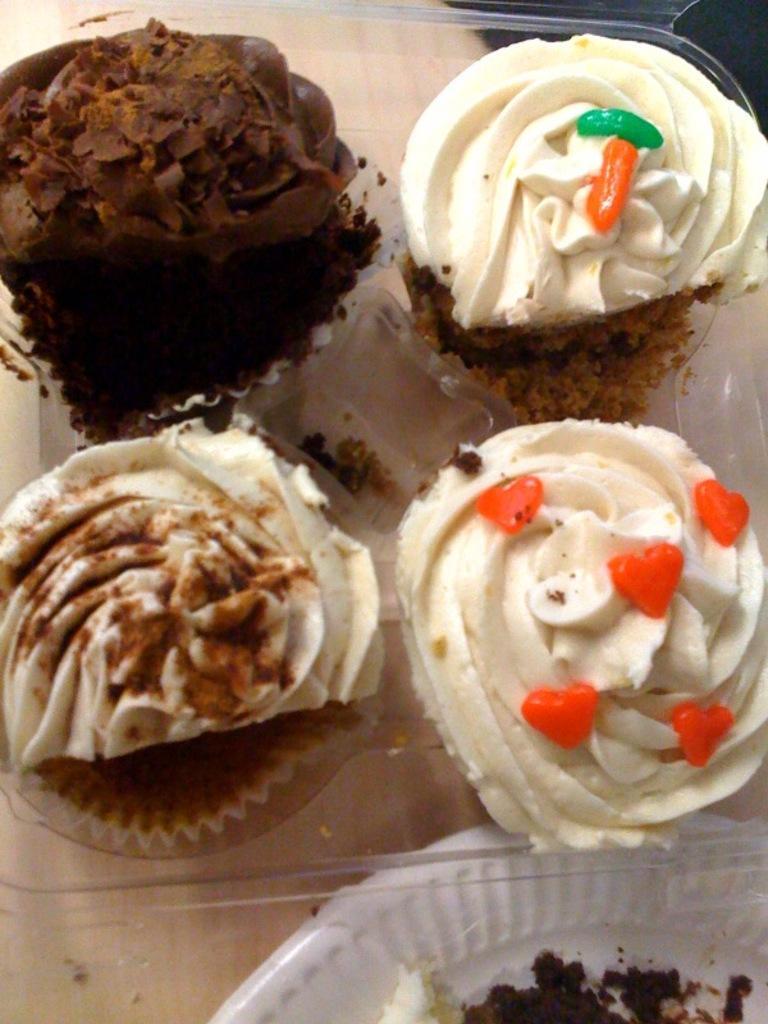Can you describe this image briefly? In this picture there are muffins in the box and there is a white plate. At the bottom there is a table. 